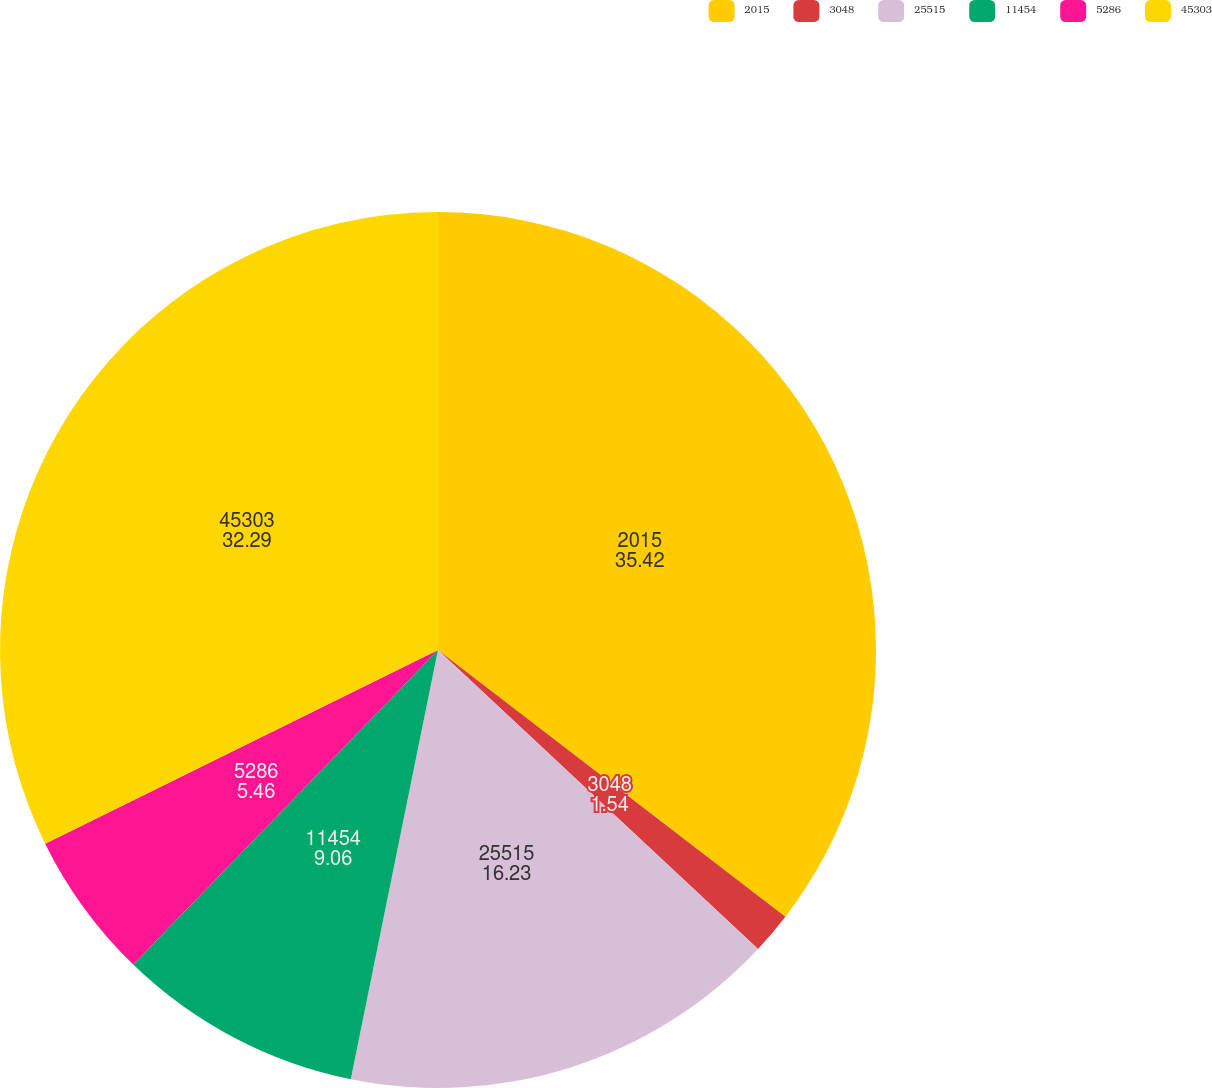Convert chart to OTSL. <chart><loc_0><loc_0><loc_500><loc_500><pie_chart><fcel>2015<fcel>3048<fcel>25515<fcel>11454<fcel>5286<fcel>45303<nl><fcel>35.42%<fcel>1.54%<fcel>16.23%<fcel>9.06%<fcel>5.46%<fcel>32.29%<nl></chart> 